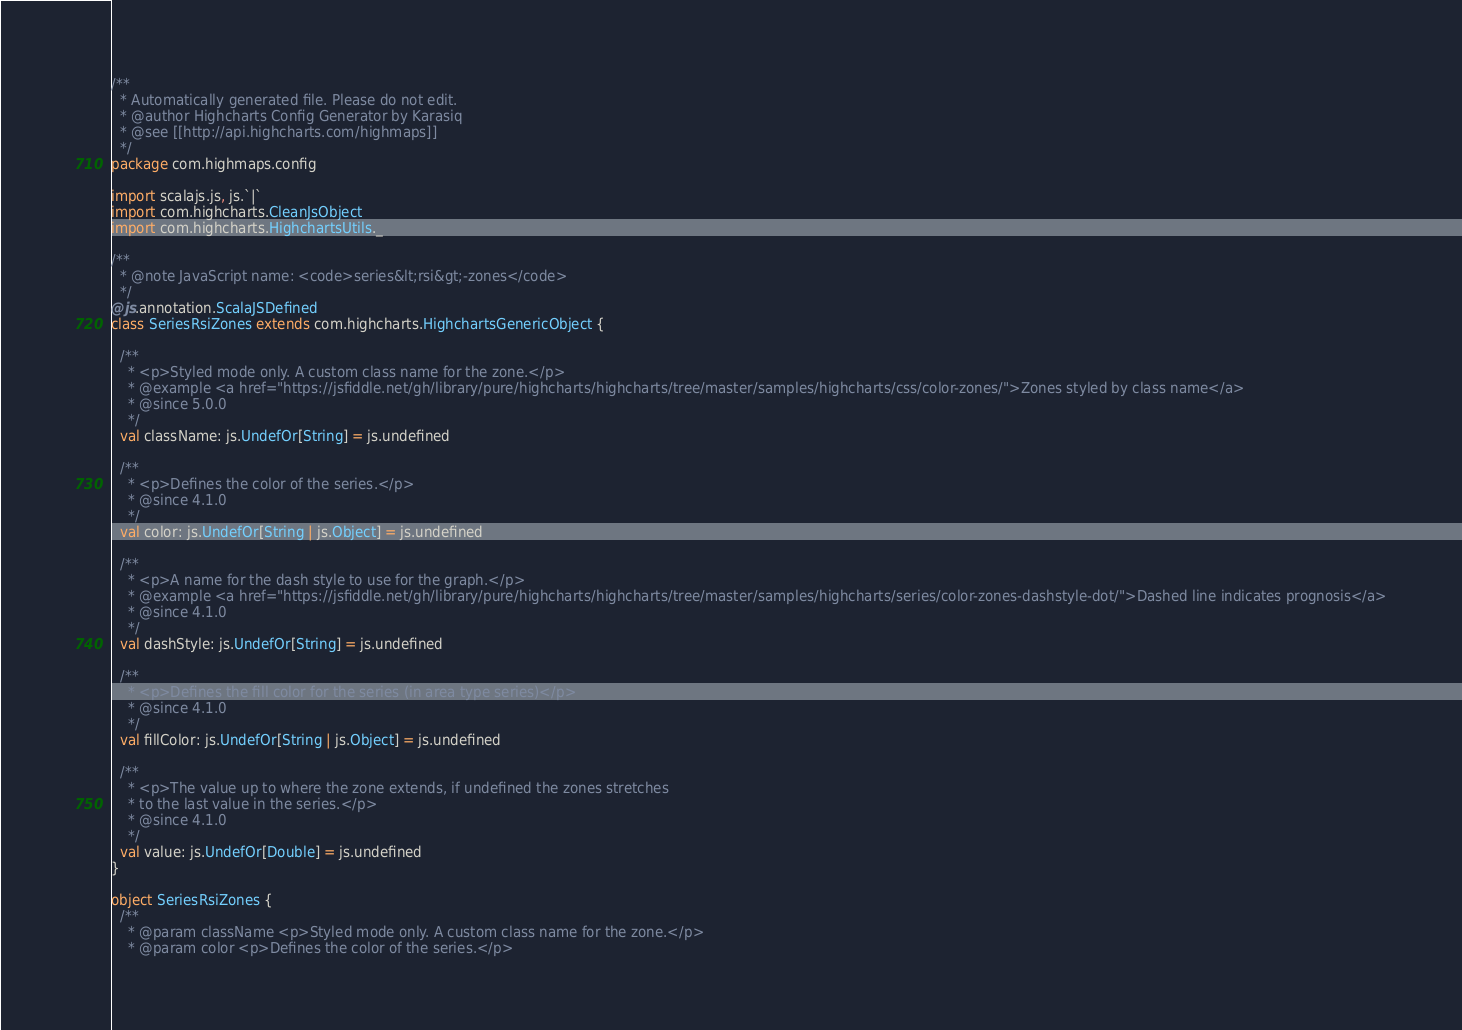Convert code to text. <code><loc_0><loc_0><loc_500><loc_500><_Scala_>/**
  * Automatically generated file. Please do not edit.
  * @author Highcharts Config Generator by Karasiq
  * @see [[http://api.highcharts.com/highmaps]]
  */
package com.highmaps.config

import scalajs.js, js.`|`
import com.highcharts.CleanJsObject
import com.highcharts.HighchartsUtils._

/**
  * @note JavaScript name: <code>series&lt;rsi&gt;-zones</code>
  */
@js.annotation.ScalaJSDefined
class SeriesRsiZones extends com.highcharts.HighchartsGenericObject {

  /**
    * <p>Styled mode only. A custom class name for the zone.</p>
    * @example <a href="https://jsfiddle.net/gh/library/pure/highcharts/highcharts/tree/master/samples/highcharts/css/color-zones/">Zones styled by class name</a>
    * @since 5.0.0
    */
  val className: js.UndefOr[String] = js.undefined

  /**
    * <p>Defines the color of the series.</p>
    * @since 4.1.0
    */
  val color: js.UndefOr[String | js.Object] = js.undefined

  /**
    * <p>A name for the dash style to use for the graph.</p>
    * @example <a href="https://jsfiddle.net/gh/library/pure/highcharts/highcharts/tree/master/samples/highcharts/series/color-zones-dashstyle-dot/">Dashed line indicates prognosis</a>
    * @since 4.1.0
    */
  val dashStyle: js.UndefOr[String] = js.undefined

  /**
    * <p>Defines the fill color for the series (in area type series)</p>
    * @since 4.1.0
    */
  val fillColor: js.UndefOr[String | js.Object] = js.undefined

  /**
    * <p>The value up to where the zone extends, if undefined the zones stretches
    * to the last value in the series.</p>
    * @since 4.1.0
    */
  val value: js.UndefOr[Double] = js.undefined
}

object SeriesRsiZones {
  /**
    * @param className <p>Styled mode only. A custom class name for the zone.</p>
    * @param color <p>Defines the color of the series.</p></code> 